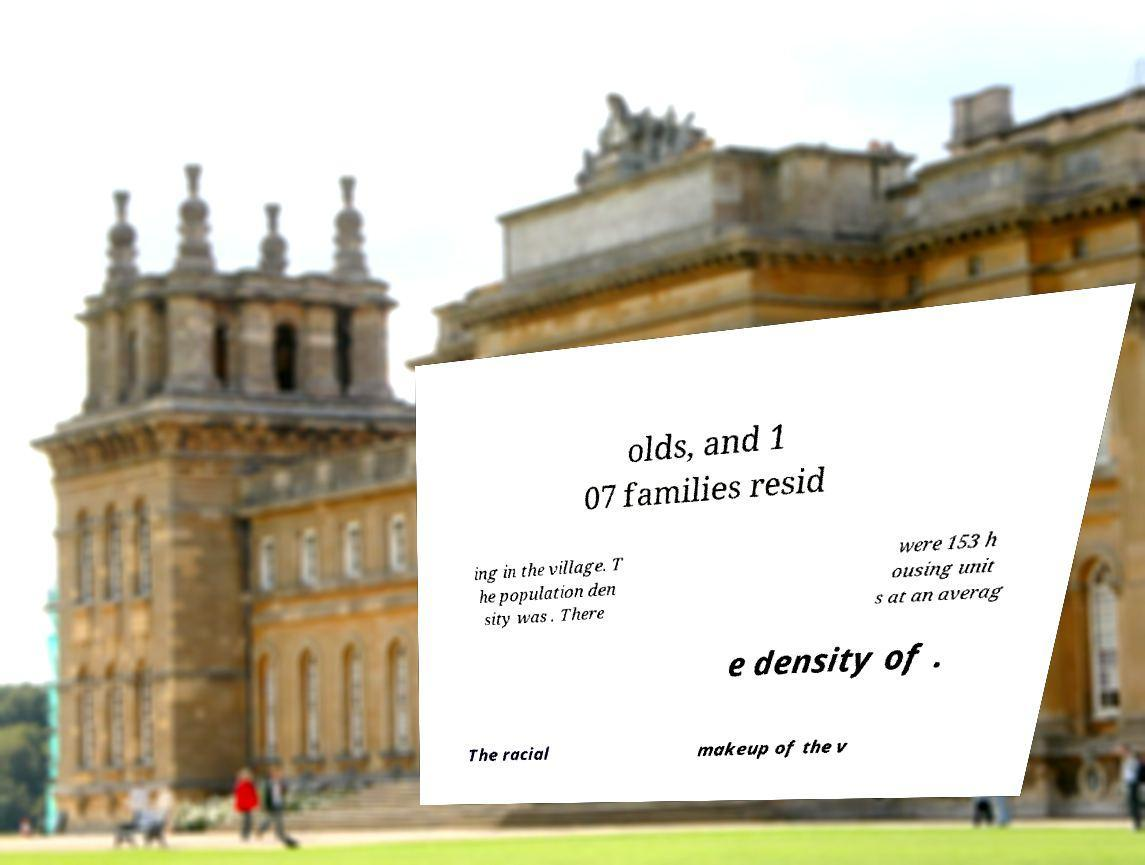Could you assist in decoding the text presented in this image and type it out clearly? olds, and 1 07 families resid ing in the village. T he population den sity was . There were 153 h ousing unit s at an averag e density of . The racial makeup of the v 